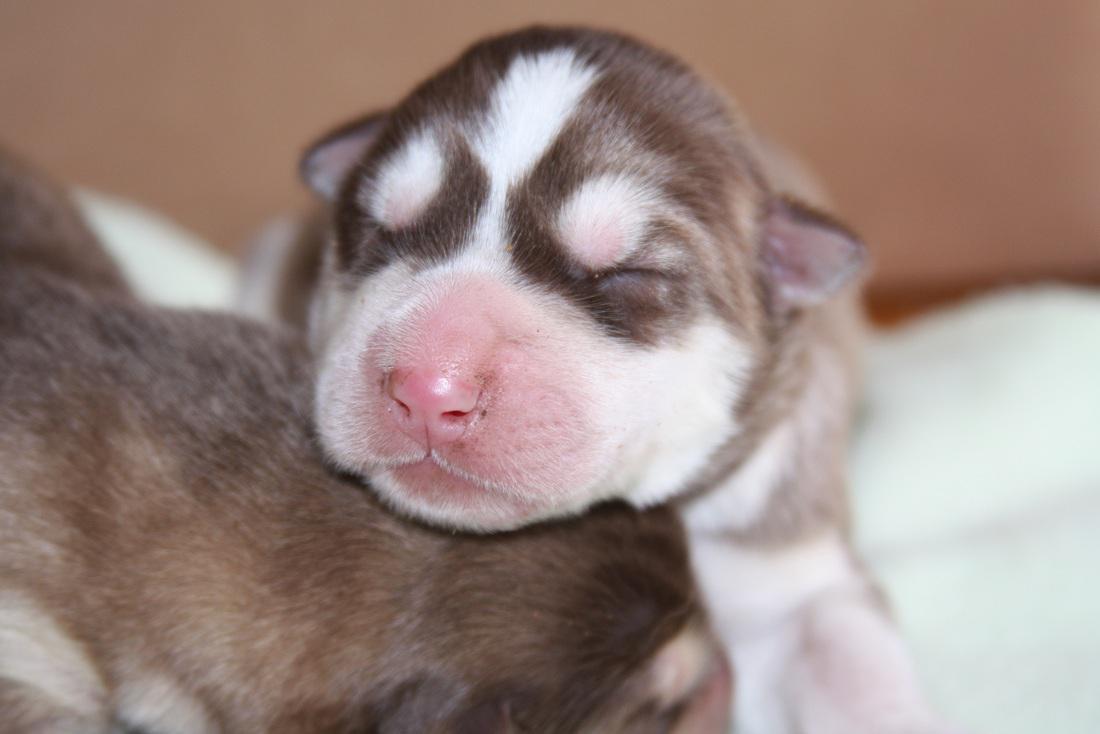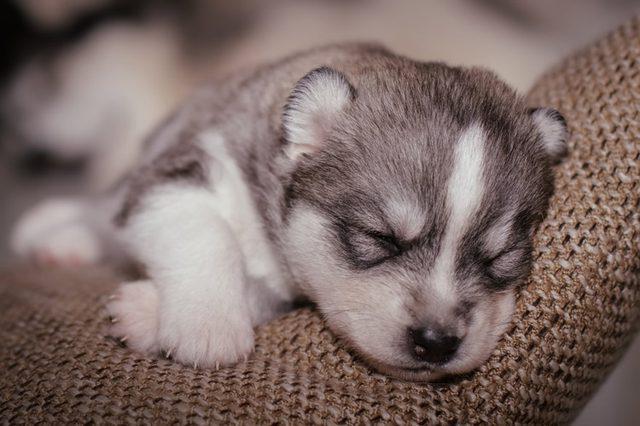The first image is the image on the left, the second image is the image on the right. Examine the images to the left and right. Is the description "One image shows a reclining mother dog with her head on the left, nursing multiple puppies with their tails toward the camera." accurate? Answer yes or no. No. 